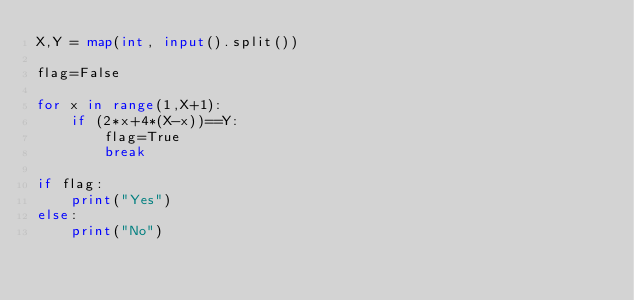Convert code to text. <code><loc_0><loc_0><loc_500><loc_500><_Python_>X,Y = map(int, input().split())

flag=False

for x in range(1,X+1):
    if (2*x+4*(X-x))==Y:
        flag=True
        break

if flag:
    print("Yes")
else:
    print("No")</code> 